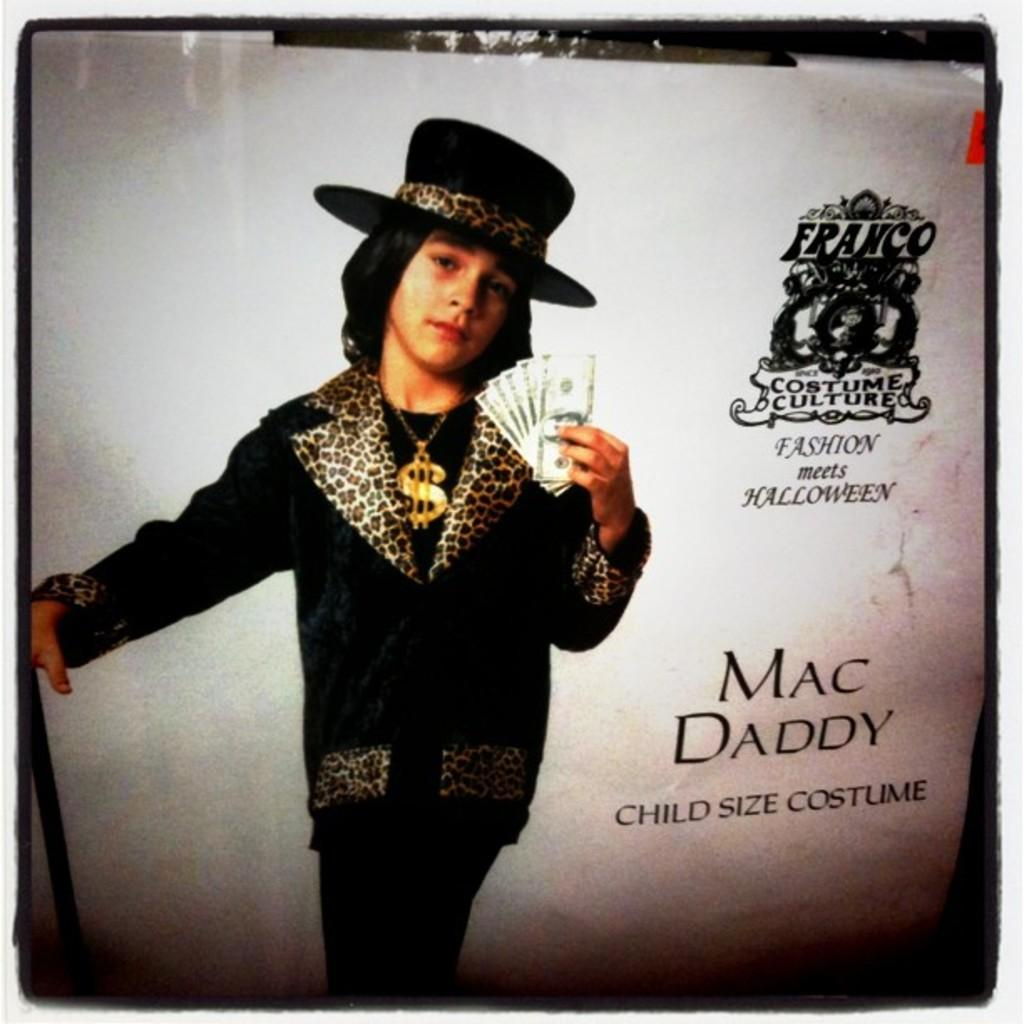What can be seen hanging on the wall in the picture? There is a poster in the picture. What is the person wearing in the picture? The person is wearing a hat in the picture. What is the person holding in the picture? The person is holding currency in the picture. What is written on the poster? There are texts on the poster. Can you see any oil dripping from the hat in the picture? There is no oil present in the image, nor is there any indication of oil dripping from the hat. 